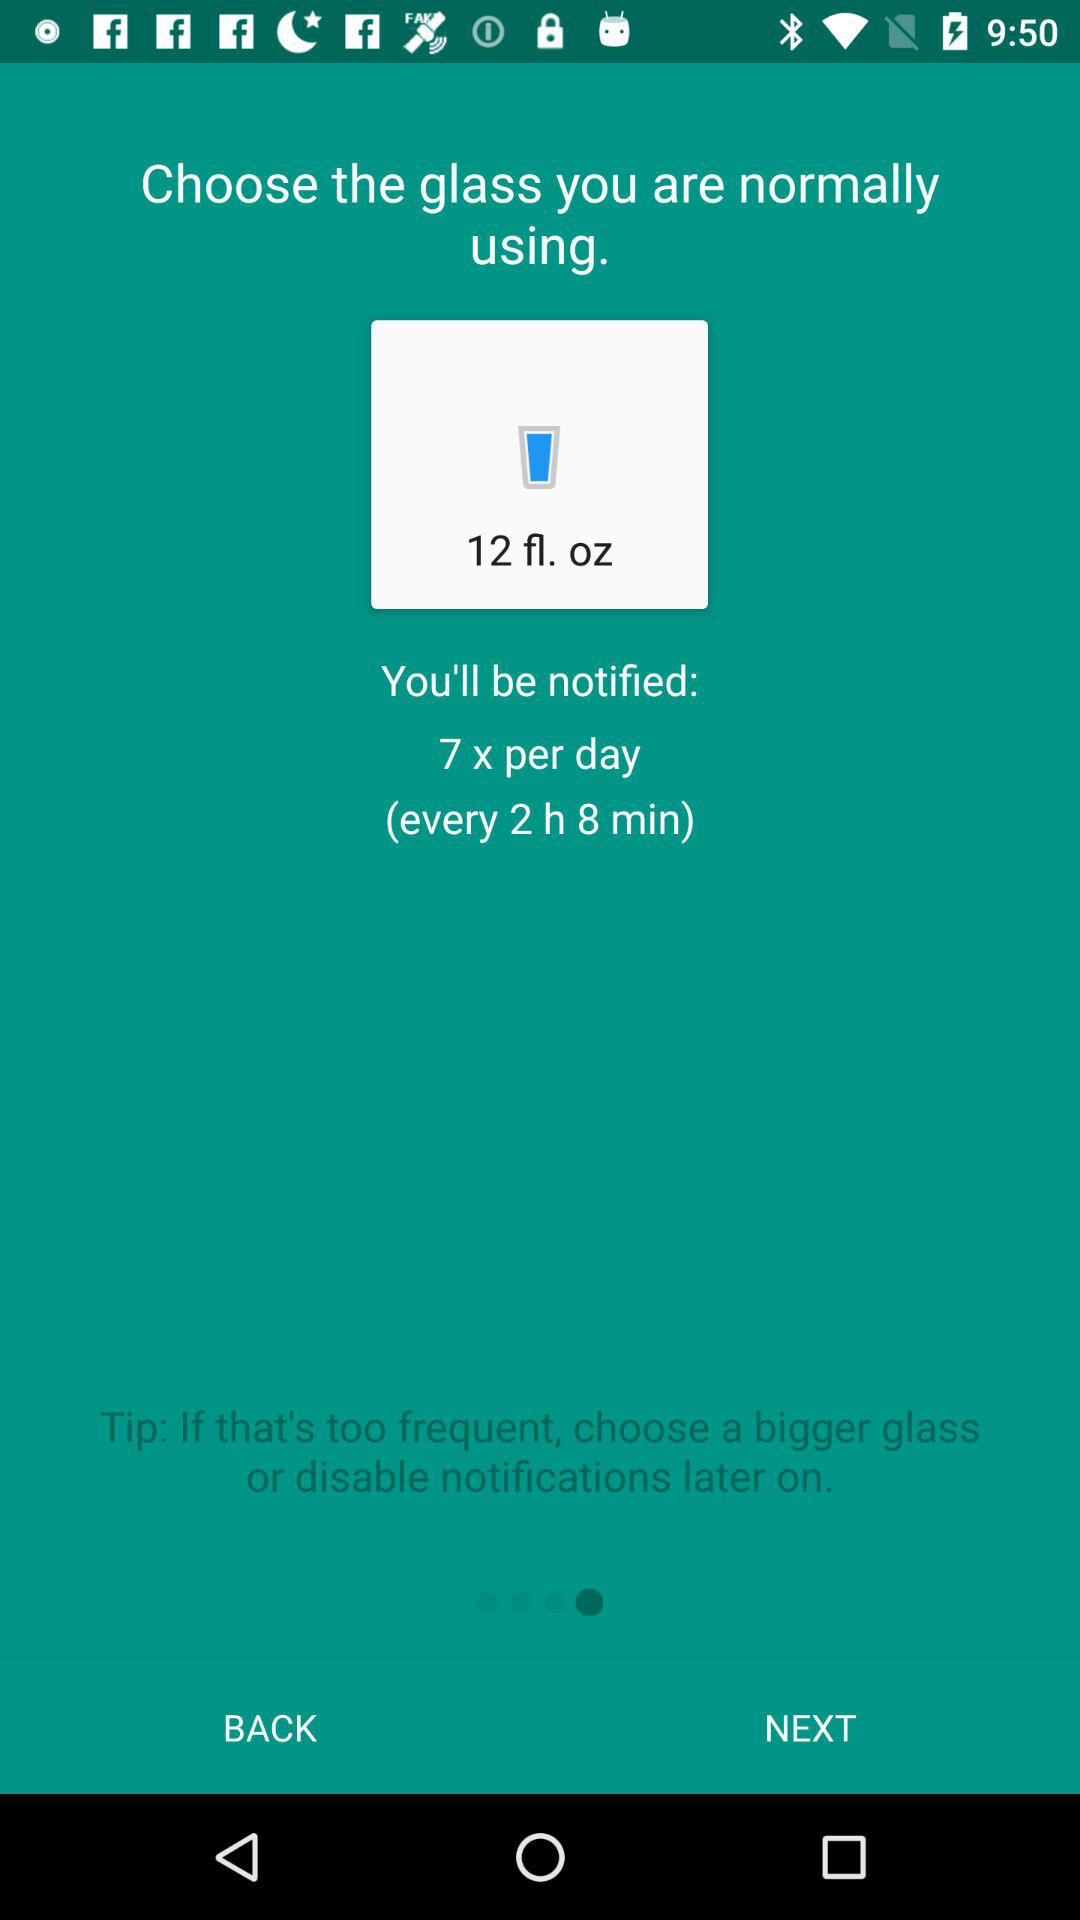What is the time interval for notification? The time interval for notification is every 2 hours 8 minutes. 